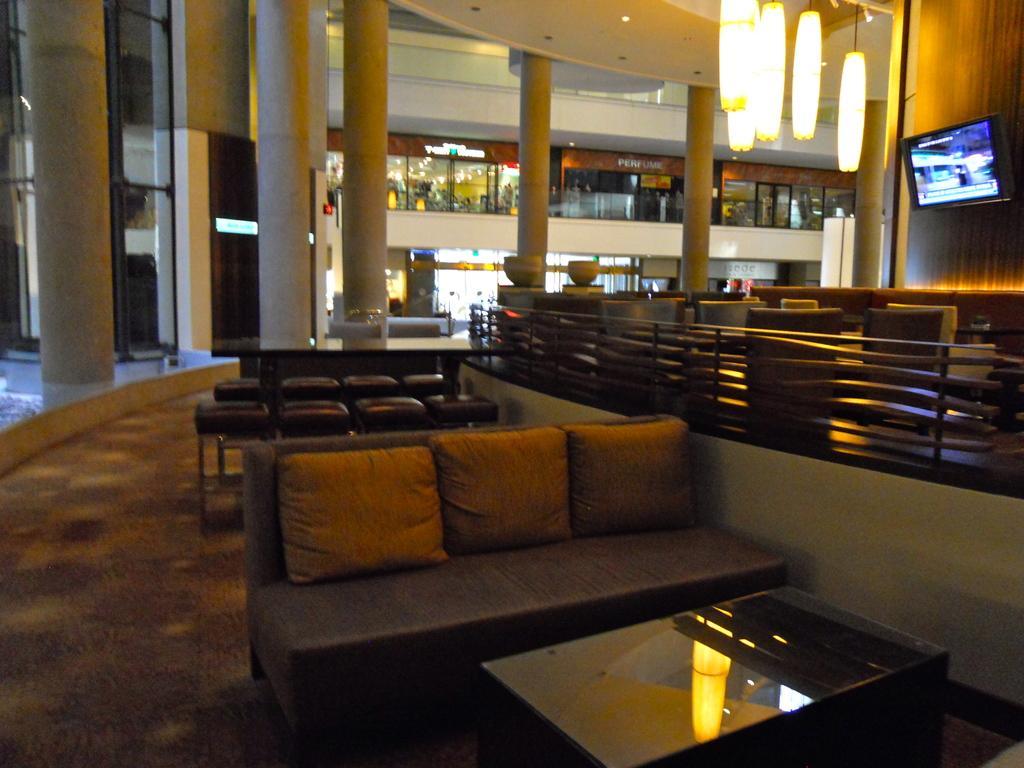In one or two sentences, can you explain what this image depicts? This is the picture taken in a room, in this room there are chairs on the chairs there are cushions in front of the table there is a table. Behind the chairs there's a wall with a television and pillars. 